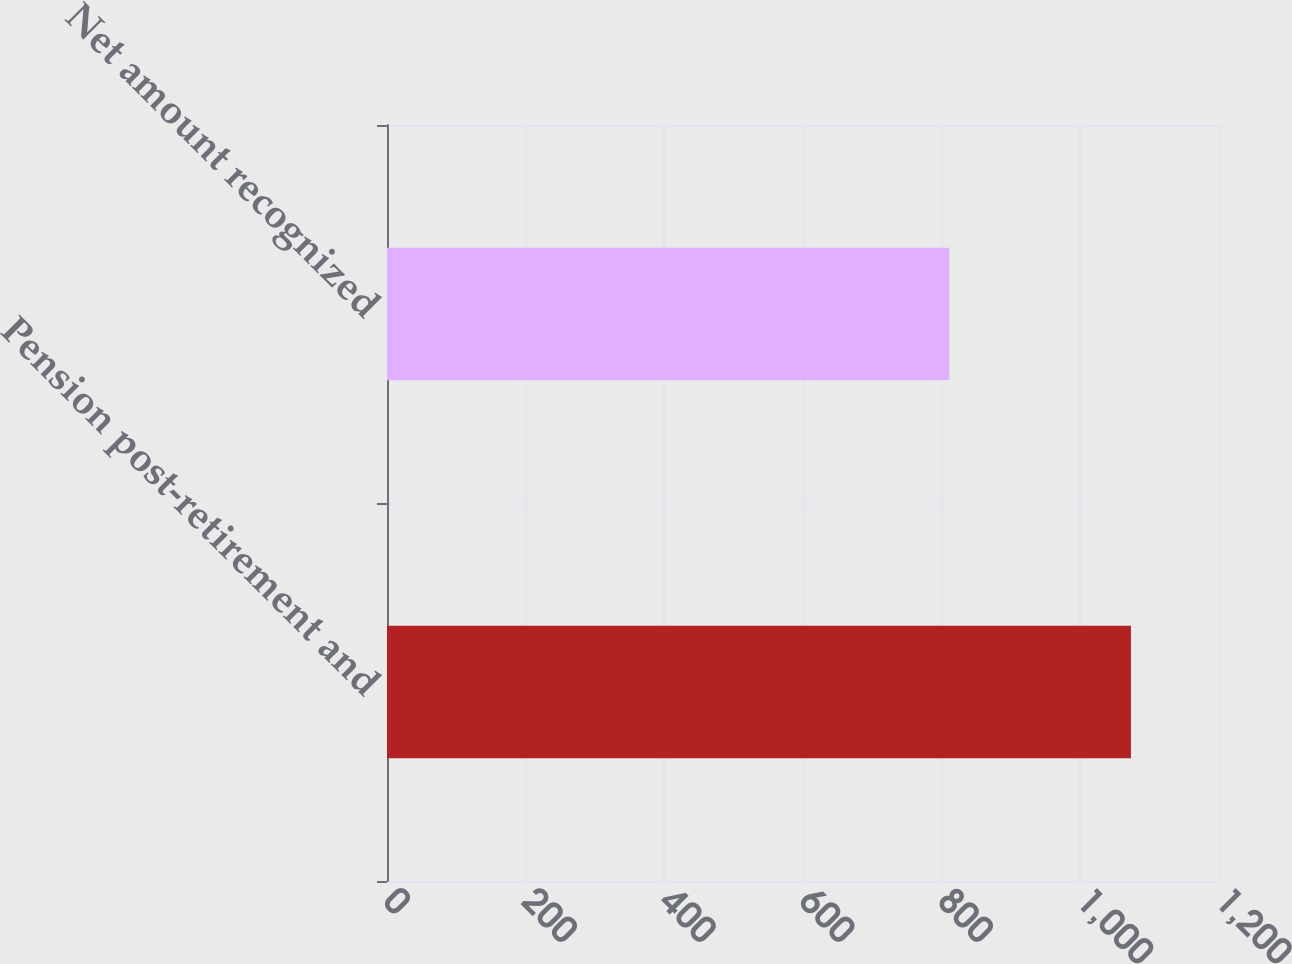Convert chart to OTSL. <chart><loc_0><loc_0><loc_500><loc_500><bar_chart><fcel>Pension post-retirement and<fcel>Net amount recognized<nl><fcel>1073<fcel>811<nl></chart> 